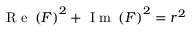<formula> <loc_0><loc_0><loc_500><loc_500>R e \left ( F \right ) ^ { 2 } + I m \left ( F \right ) ^ { 2 } = r ^ { 2 }</formula> 